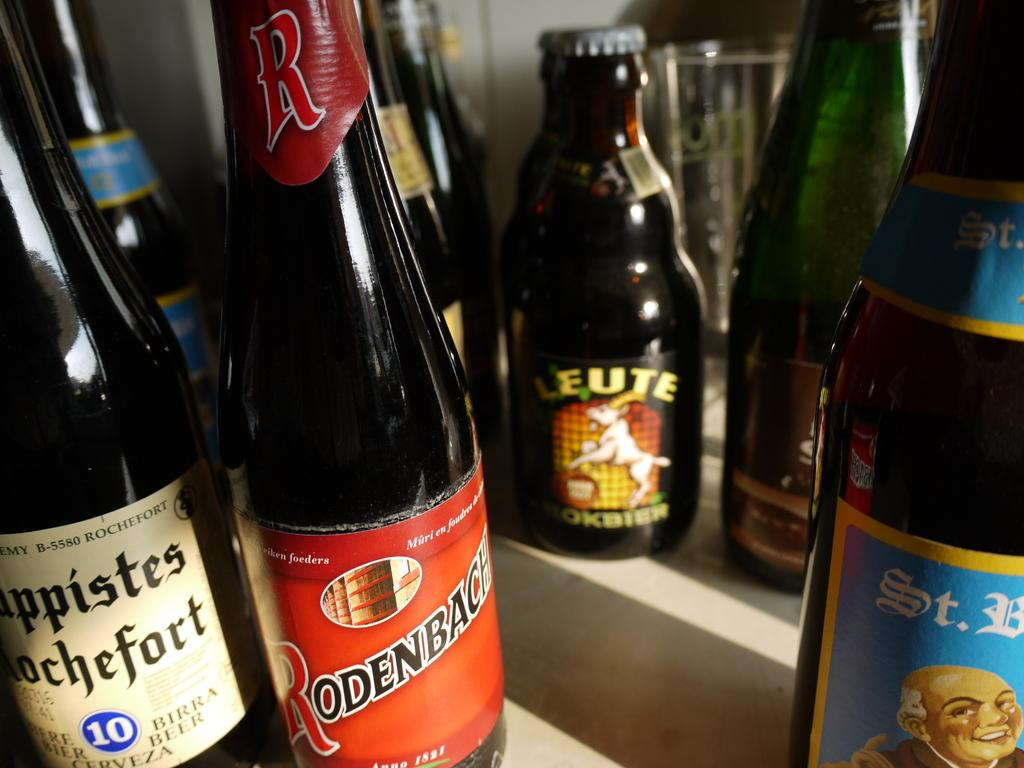Provide a one-sentence caption for the provided image. Several wines are available including a bottle of Rodenbach. 